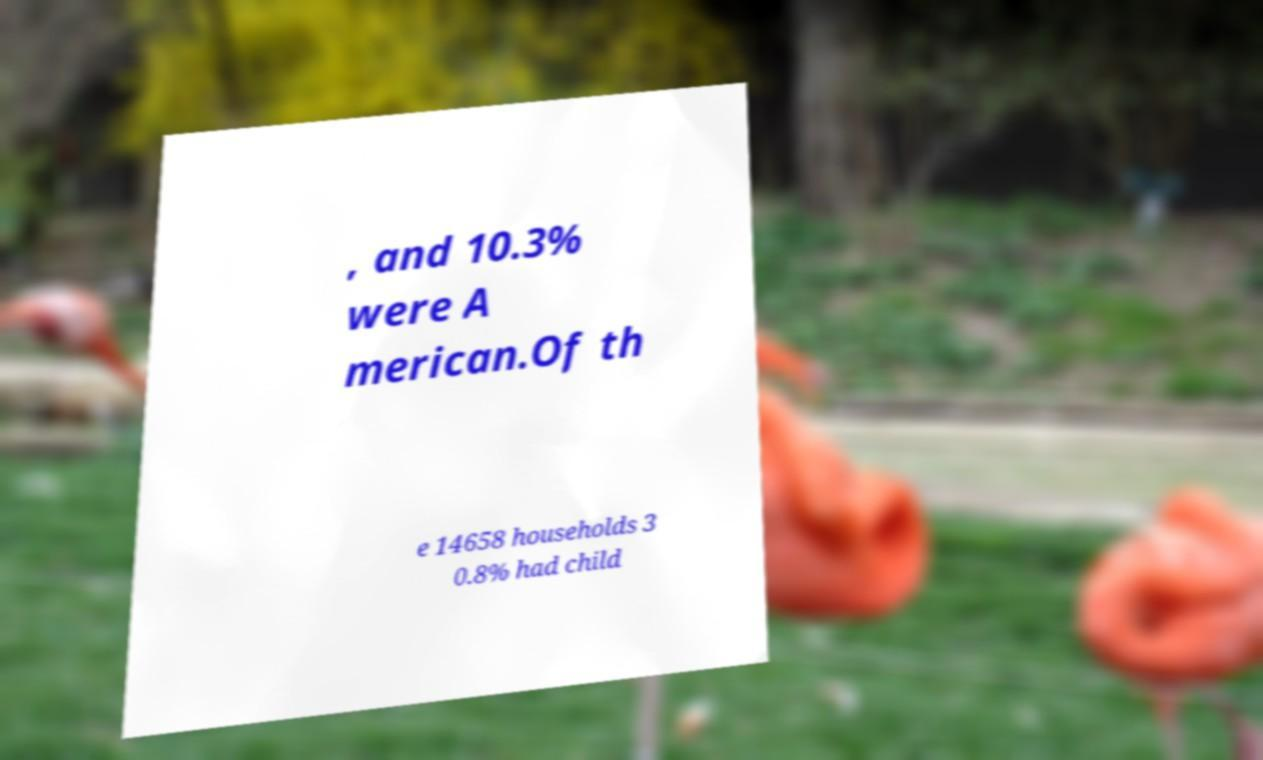Can you accurately transcribe the text from the provided image for me? , and 10.3% were A merican.Of th e 14658 households 3 0.8% had child 